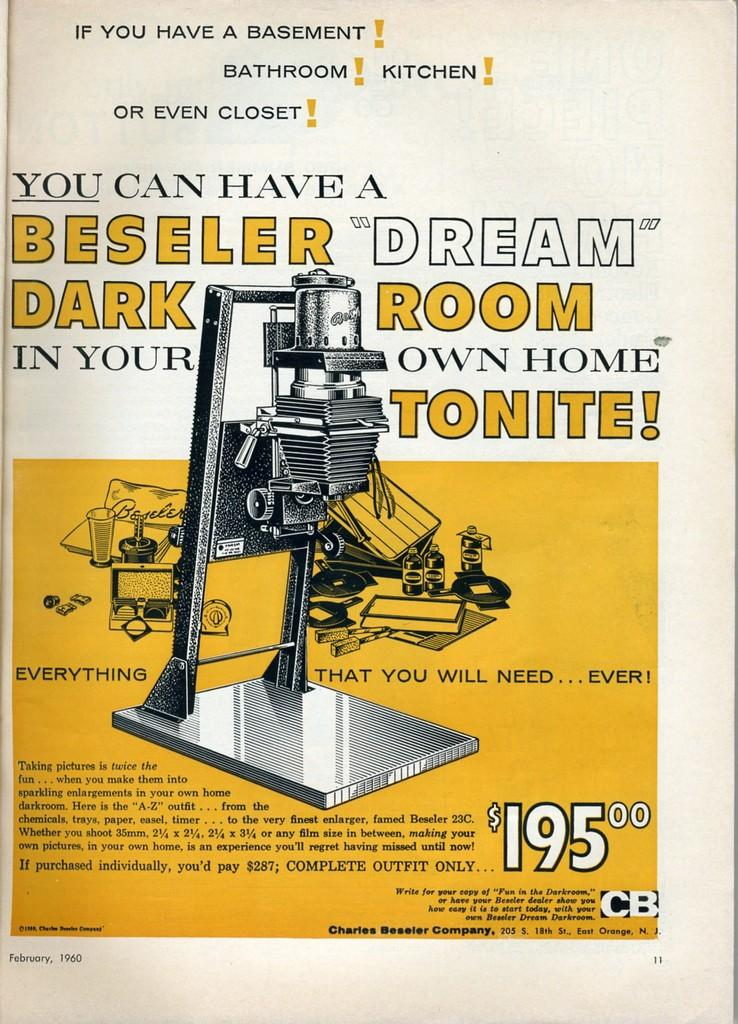<image>
Offer a succinct explanation of the picture presented. An advertisement for a dark room product for 195 